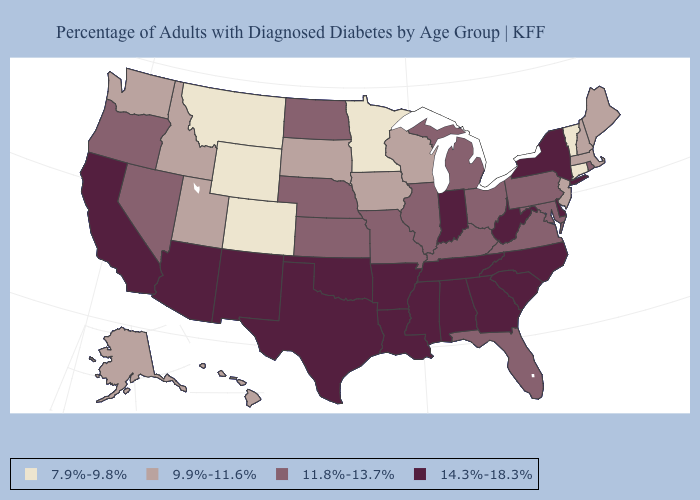What is the value of West Virginia?
Keep it brief. 14.3%-18.3%. Among the states that border South Dakota , which have the highest value?
Quick response, please. Nebraska, North Dakota. Name the states that have a value in the range 7.9%-9.8%?
Give a very brief answer. Colorado, Connecticut, Minnesota, Montana, Vermont, Wyoming. Does the map have missing data?
Answer briefly. No. Does Kentucky have the highest value in the South?
Keep it brief. No. Does West Virginia have a lower value than Colorado?
Keep it brief. No. What is the value of New Jersey?
Keep it brief. 9.9%-11.6%. What is the lowest value in the USA?
Write a very short answer. 7.9%-9.8%. Does Wyoming have the lowest value in the West?
Quick response, please. Yes. Does Utah have a lower value than Michigan?
Give a very brief answer. Yes. What is the lowest value in the South?
Keep it brief. 11.8%-13.7%. Does West Virginia have the highest value in the South?
Give a very brief answer. Yes. Does Louisiana have the lowest value in the South?
Quick response, please. No. Does the map have missing data?
Answer briefly. No. 